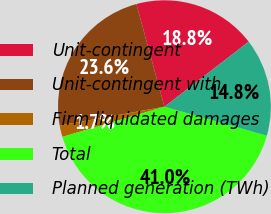<chart> <loc_0><loc_0><loc_500><loc_500><pie_chart><fcel>Unit-contingent<fcel>Unit-contingent with<fcel>Firm liquidated damages<fcel>Total<fcel>Planned generation (TWh)<nl><fcel>18.78%<fcel>23.58%<fcel>1.75%<fcel>41.05%<fcel>14.85%<nl></chart> 